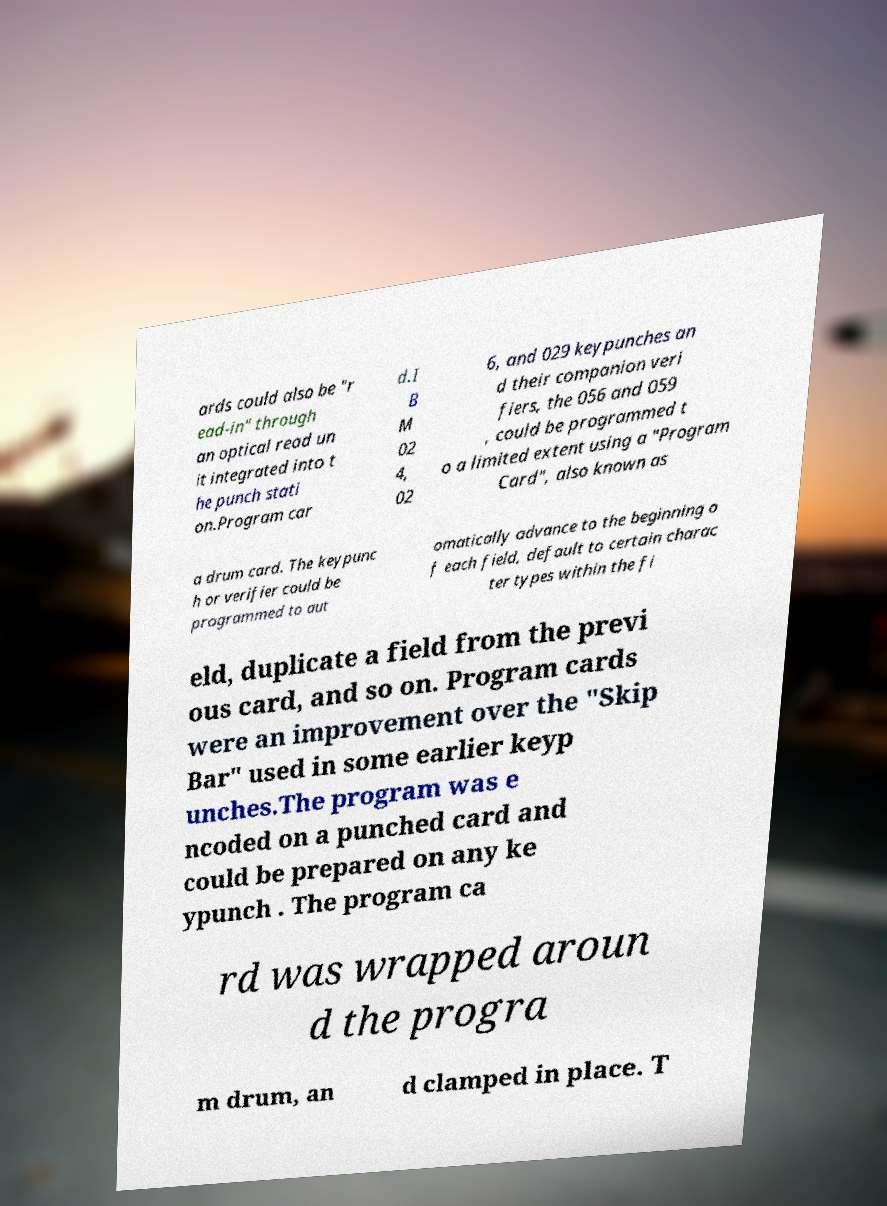I need the written content from this picture converted into text. Can you do that? ards could also be "r ead-in" through an optical read un it integrated into t he punch stati on.Program car d.I B M 02 4, 02 6, and 029 keypunches an d their companion veri fiers, the 056 and 059 , could be programmed t o a limited extent using a "Program Card", also known as a drum card. The keypunc h or verifier could be programmed to aut omatically advance to the beginning o f each field, default to certain charac ter types within the fi eld, duplicate a field from the previ ous card, and so on. Program cards were an improvement over the "Skip Bar" used in some earlier keyp unches.The program was e ncoded on a punched card and could be prepared on any ke ypunch . The program ca rd was wrapped aroun d the progra m drum, an d clamped in place. T 